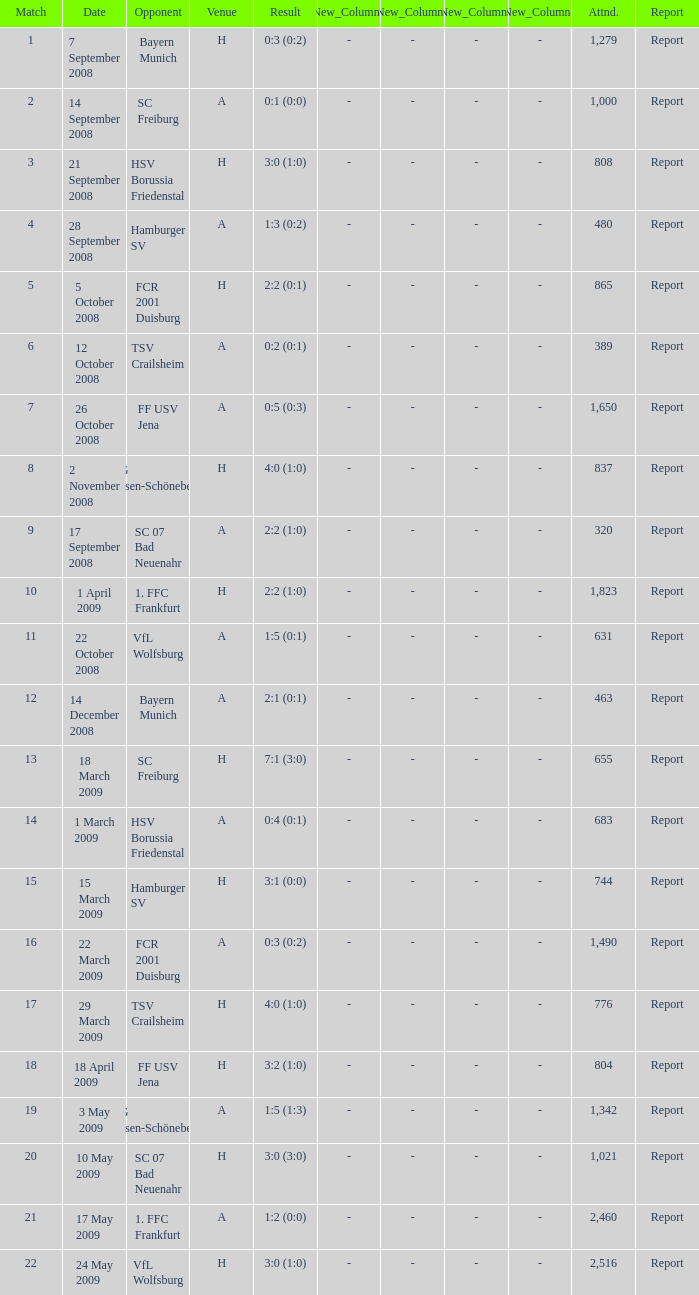Which match had more than 1,490 people in attendance to watch FCR 2001 Duisburg have a result of 0:3 (0:2)? None. 